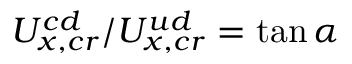Convert formula to latex. <formula><loc_0><loc_0><loc_500><loc_500>U _ { x , c r } ^ { c d } / U _ { x , c r } ^ { u d } = \tan \alpha</formula> 